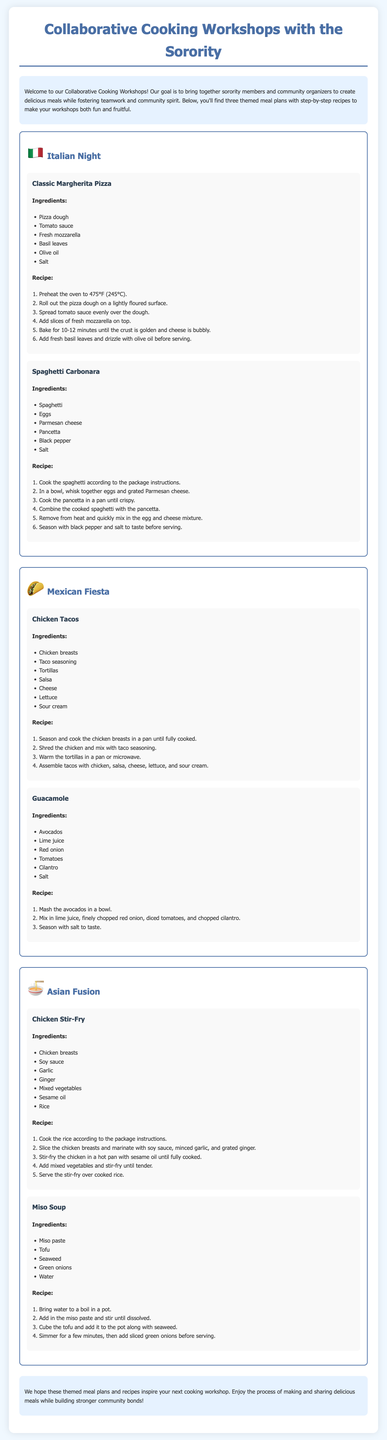What is the first themed meal plan mentioned? The first themed meal plan is presented under the title "Italian Night" in the document.
Answer: Italian Night How many ingredients are listed for the Classic Margherita Pizza? The ingredients for Classic Margherita Pizza include a list of six items, highlighting the variety necessary for the dish.
Answer: 6 What do you need to preheat the oven to for baking the Classic Margherita Pizza? The recipe mentions preheating the oven to 475°F (245°C) to ensure the pizza bakes properly.
Answer: 475°F What is the main protein used in the Chicken Tacos recipe? The recipe for Chicken Tacos specifies chicken breasts as the primary source of protein in the dish.
Answer: Chicken breasts Which themed meal plan includes a dish called Miso Soup? The document categorizes Miso Soup under the "Asian Fusion" meal plan, showcasing a different culinary culture.
Answer: Asian Fusion How long should you bake the Classic Margherita Pizza? The cooking instructions specify a baking duration of 10-12 minutes for the pizza until it's properly cooked.
Answer: 10-12 minutes What is the last theme presented in the meal plans? The last meal plan presented is labeled "Asian Fusion," marking the conclusion of the themed sections.
Answer: Asian Fusion What is the application of sesame oil in the Chicken Stir-Fry recipe? The Cooking instructions specifically mention adding sesame oil while stir-frying to impart flavor to the dish.
Answer: Stir-frying How is the guacamole seasoned according to the recipe? The recipe states that guacamole is seasoned with salt to taste, emphasizing the importance of flavor balance.
Answer: Salt 